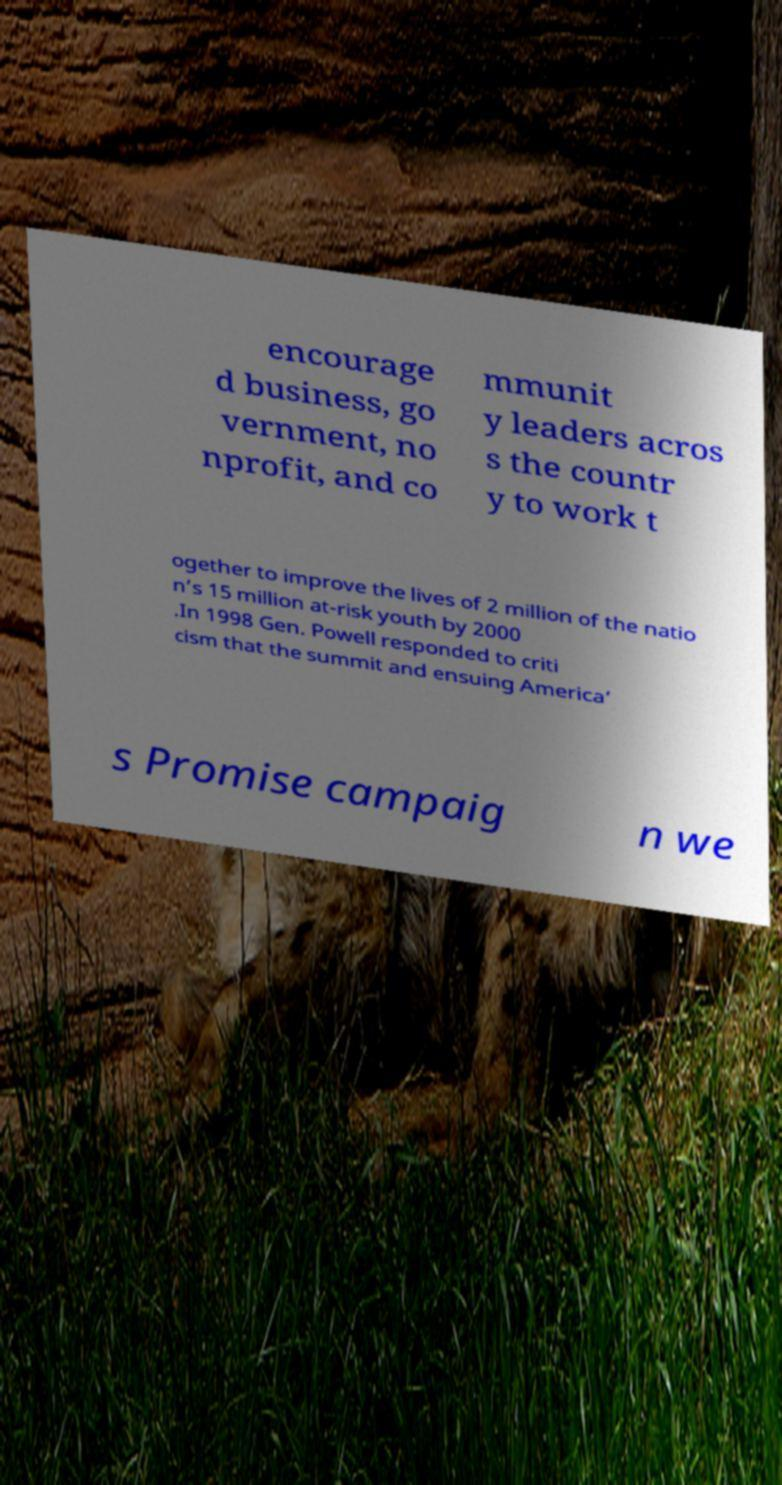Can you accurately transcribe the text from the provided image for me? encourage d business, go vernment, no nprofit, and co mmunit y leaders acros s the countr y to work t ogether to improve the lives of 2 million of the natio n’s 15 million at-risk youth by 2000 .In 1998 Gen. Powell responded to criti cism that the summit and ensuing America’ s Promise campaig n we 